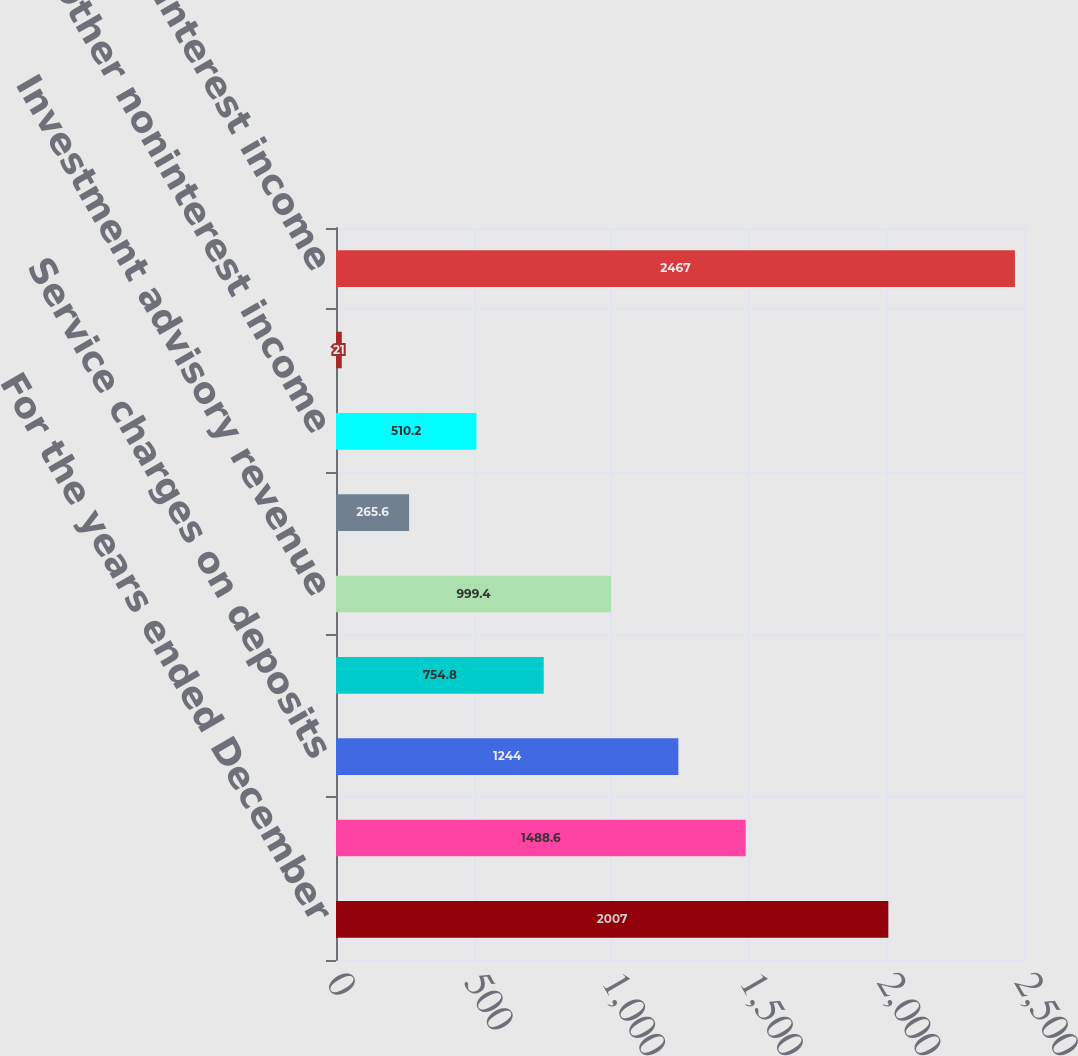Convert chart to OTSL. <chart><loc_0><loc_0><loc_500><loc_500><bar_chart><fcel>For the years ended December<fcel>Electronic payment processing<fcel>Service charges on deposits<fcel>Corporate banking revenue<fcel>Investment advisory revenue<fcel>Mortgage banking net revenue<fcel>Other noninterest income<fcel>Securities gains (losses) net<fcel>Total noninterest income<nl><fcel>2007<fcel>1488.6<fcel>1244<fcel>754.8<fcel>999.4<fcel>265.6<fcel>510.2<fcel>21<fcel>2467<nl></chart> 